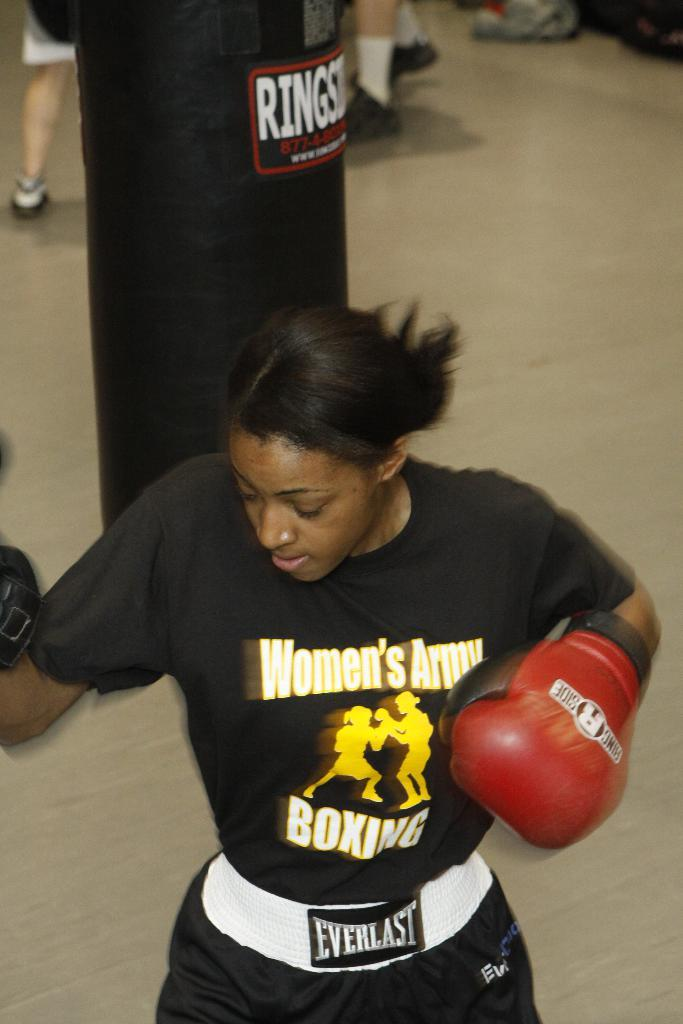Provide a one-sentence caption for the provided image. A boxer is wearing a shirt that says, "Women's Army Boxing" in white letters. 